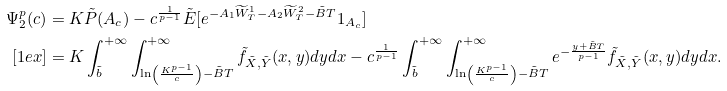Convert formula to latex. <formula><loc_0><loc_0><loc_500><loc_500>\Psi _ { 2 } ^ { p } ( c ) & = K \tilde { P } ( A _ { c } ) - c ^ { \frac { 1 } { p - 1 } } \tilde { E } [ e ^ { - A _ { 1 } \widetilde { W } ^ { 1 } _ { T } - A _ { 2 } \widetilde { W } ^ { 2 } _ { T } - \tilde { B } T } 1 _ { A _ { c } } ] \\ [ 1 e x ] & = K \int _ { \tilde { b } } ^ { + \infty } \int _ { \ln \left ( \frac { K ^ { p - 1 } } { c } \right ) - \tilde { B } T } ^ { + \infty } \tilde { f } _ { \tilde { X } , \tilde { Y } } ( x , y ) d y d x - c ^ { \frac { 1 } { p - 1 } } \int _ { \tilde { b } } ^ { + \infty } \int _ { \ln \left ( \frac { K ^ { p - 1 } } { c } \right ) - \tilde { B } T } ^ { + \infty } e ^ { - \frac { y + \tilde { B } T } { p - 1 } } \tilde { f } _ { \tilde { X } , \tilde { Y } } ( x , y ) d y d x .</formula> 